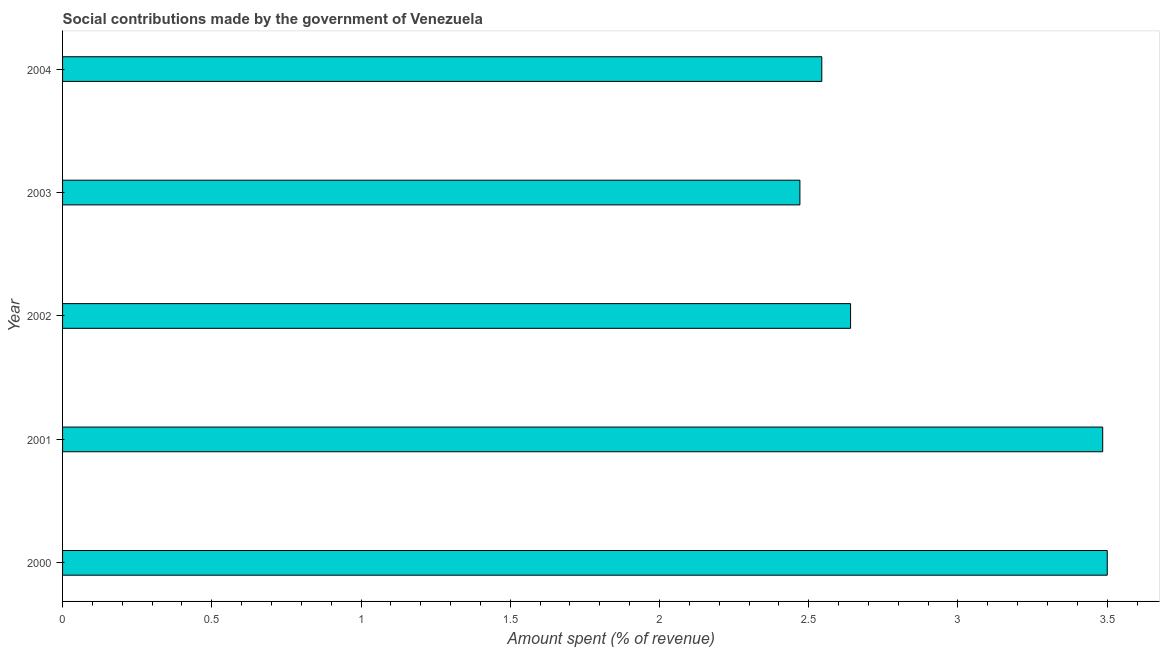Does the graph contain any zero values?
Ensure brevity in your answer.  No. What is the title of the graph?
Keep it short and to the point. Social contributions made by the government of Venezuela. What is the label or title of the X-axis?
Keep it short and to the point. Amount spent (% of revenue). What is the label or title of the Y-axis?
Provide a short and direct response. Year. What is the amount spent in making social contributions in 2003?
Give a very brief answer. 2.47. Across all years, what is the maximum amount spent in making social contributions?
Your answer should be very brief. 3.5. Across all years, what is the minimum amount spent in making social contributions?
Make the answer very short. 2.47. What is the sum of the amount spent in making social contributions?
Provide a short and direct response. 14.64. What is the difference between the amount spent in making social contributions in 2001 and 2003?
Give a very brief answer. 1.01. What is the average amount spent in making social contributions per year?
Keep it short and to the point. 2.93. What is the median amount spent in making social contributions?
Your answer should be very brief. 2.64. What is the ratio of the amount spent in making social contributions in 2000 to that in 2004?
Your response must be concise. 1.38. Is the difference between the amount spent in making social contributions in 2000 and 2004 greater than the difference between any two years?
Your answer should be very brief. No. What is the difference between the highest and the second highest amount spent in making social contributions?
Make the answer very short. 0.01. Is the sum of the amount spent in making social contributions in 2002 and 2003 greater than the maximum amount spent in making social contributions across all years?
Your answer should be compact. Yes. How many bars are there?
Make the answer very short. 5. What is the difference between two consecutive major ticks on the X-axis?
Your response must be concise. 0.5. Are the values on the major ticks of X-axis written in scientific E-notation?
Provide a succinct answer. No. What is the Amount spent (% of revenue) of 2000?
Your answer should be compact. 3.5. What is the Amount spent (% of revenue) of 2001?
Your answer should be compact. 3.49. What is the Amount spent (% of revenue) in 2002?
Provide a short and direct response. 2.64. What is the Amount spent (% of revenue) of 2003?
Your answer should be very brief. 2.47. What is the Amount spent (% of revenue) of 2004?
Ensure brevity in your answer.  2.54. What is the difference between the Amount spent (% of revenue) in 2000 and 2001?
Your response must be concise. 0.02. What is the difference between the Amount spent (% of revenue) in 2000 and 2002?
Your answer should be very brief. 0.86. What is the difference between the Amount spent (% of revenue) in 2000 and 2003?
Your answer should be very brief. 1.03. What is the difference between the Amount spent (% of revenue) in 2000 and 2004?
Your response must be concise. 0.96. What is the difference between the Amount spent (% of revenue) in 2001 and 2002?
Provide a succinct answer. 0.84. What is the difference between the Amount spent (% of revenue) in 2001 and 2003?
Keep it short and to the point. 1.01. What is the difference between the Amount spent (% of revenue) in 2001 and 2004?
Your response must be concise. 0.94. What is the difference between the Amount spent (% of revenue) in 2002 and 2003?
Provide a succinct answer. 0.17. What is the difference between the Amount spent (% of revenue) in 2002 and 2004?
Offer a terse response. 0.1. What is the difference between the Amount spent (% of revenue) in 2003 and 2004?
Your answer should be compact. -0.07. What is the ratio of the Amount spent (% of revenue) in 2000 to that in 2001?
Provide a short and direct response. 1. What is the ratio of the Amount spent (% of revenue) in 2000 to that in 2002?
Your answer should be compact. 1.33. What is the ratio of the Amount spent (% of revenue) in 2000 to that in 2003?
Offer a very short reply. 1.42. What is the ratio of the Amount spent (% of revenue) in 2000 to that in 2004?
Keep it short and to the point. 1.38. What is the ratio of the Amount spent (% of revenue) in 2001 to that in 2002?
Your response must be concise. 1.32. What is the ratio of the Amount spent (% of revenue) in 2001 to that in 2003?
Keep it short and to the point. 1.41. What is the ratio of the Amount spent (% of revenue) in 2001 to that in 2004?
Give a very brief answer. 1.37. What is the ratio of the Amount spent (% of revenue) in 2002 to that in 2003?
Offer a terse response. 1.07. What is the ratio of the Amount spent (% of revenue) in 2002 to that in 2004?
Keep it short and to the point. 1.04. 